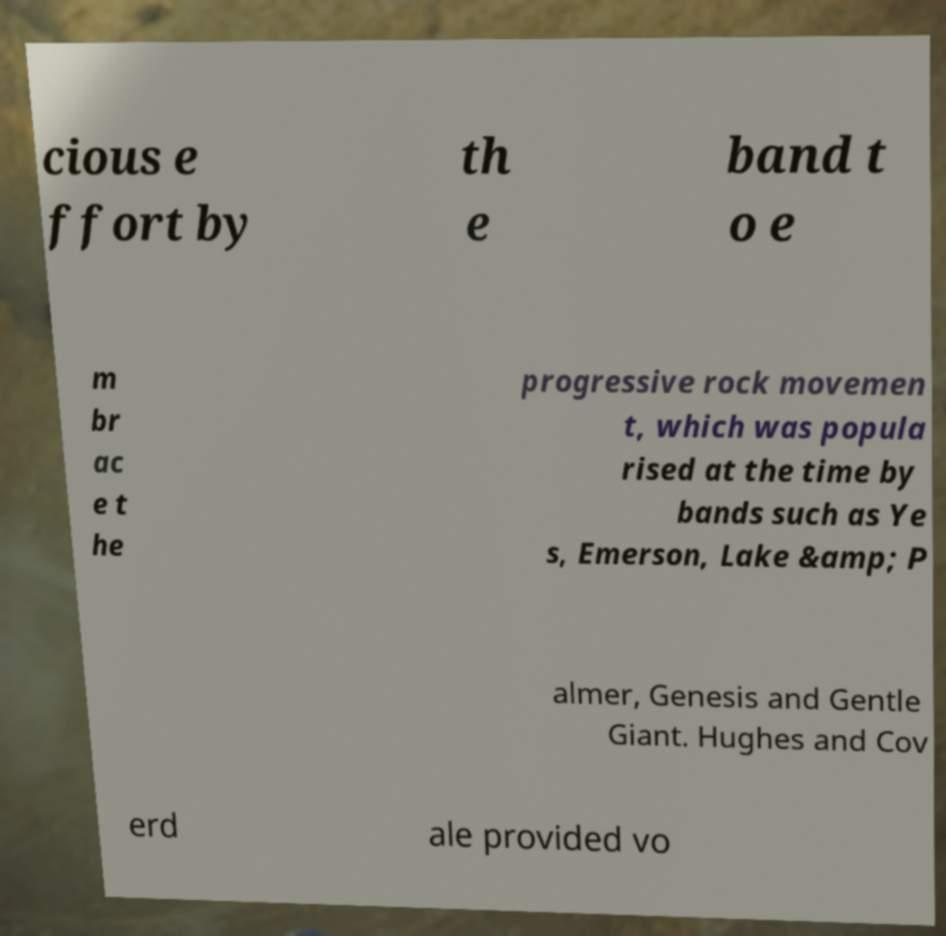Please read and relay the text visible in this image. What does it say? cious e ffort by th e band t o e m br ac e t he progressive rock movemen t, which was popula rised at the time by bands such as Ye s, Emerson, Lake &amp; P almer, Genesis and Gentle Giant. Hughes and Cov erd ale provided vo 